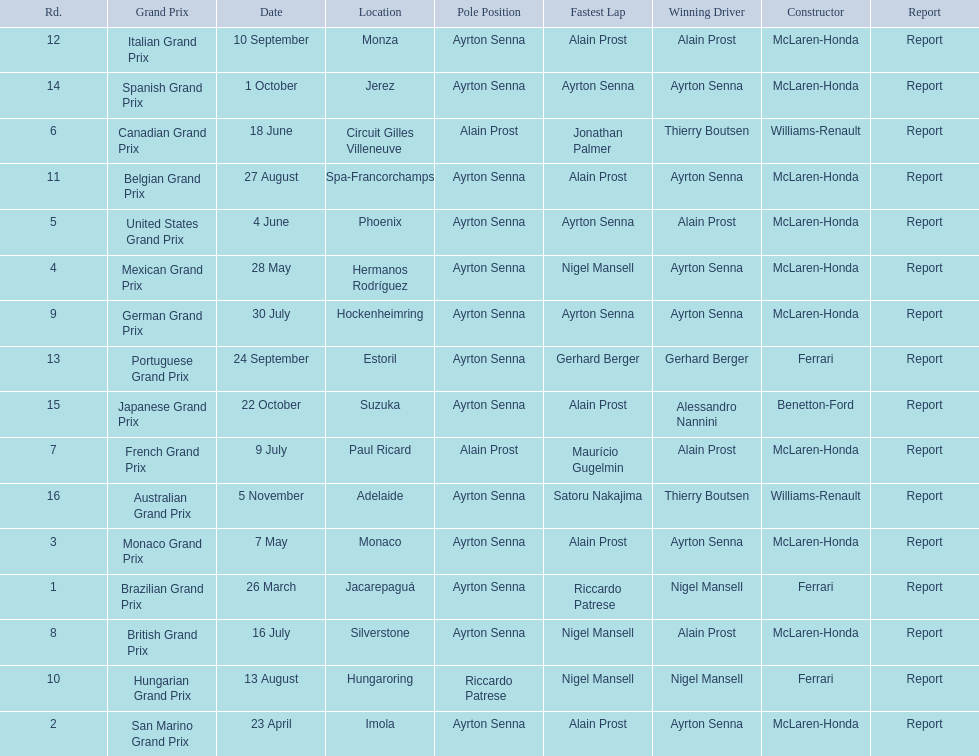Would you mind parsing the complete table? {'header': ['Rd.', 'Grand Prix', 'Date', 'Location', 'Pole Position', 'Fastest Lap', 'Winning Driver', 'Constructor', 'Report'], 'rows': [['12', 'Italian Grand Prix', '10 September', 'Monza', 'Ayrton Senna', 'Alain Prost', 'Alain Prost', 'McLaren-Honda', 'Report'], ['14', 'Spanish Grand Prix', '1 October', 'Jerez', 'Ayrton Senna', 'Ayrton Senna', 'Ayrton Senna', 'McLaren-Honda', 'Report'], ['6', 'Canadian Grand Prix', '18 June', 'Circuit Gilles Villeneuve', 'Alain Prost', 'Jonathan Palmer', 'Thierry Boutsen', 'Williams-Renault', 'Report'], ['11', 'Belgian Grand Prix', '27 August', 'Spa-Francorchamps', 'Ayrton Senna', 'Alain Prost', 'Ayrton Senna', 'McLaren-Honda', 'Report'], ['5', 'United States Grand Prix', '4 June', 'Phoenix', 'Ayrton Senna', 'Ayrton Senna', 'Alain Prost', 'McLaren-Honda', 'Report'], ['4', 'Mexican Grand Prix', '28 May', 'Hermanos Rodríguez', 'Ayrton Senna', 'Nigel Mansell', 'Ayrton Senna', 'McLaren-Honda', 'Report'], ['9', 'German Grand Prix', '30 July', 'Hockenheimring', 'Ayrton Senna', 'Ayrton Senna', 'Ayrton Senna', 'McLaren-Honda', 'Report'], ['13', 'Portuguese Grand Prix', '24 September', 'Estoril', 'Ayrton Senna', 'Gerhard Berger', 'Gerhard Berger', 'Ferrari', 'Report'], ['15', 'Japanese Grand Prix', '22 October', 'Suzuka', 'Ayrton Senna', 'Alain Prost', 'Alessandro Nannini', 'Benetton-Ford', 'Report'], ['7', 'French Grand Prix', '9 July', 'Paul Ricard', 'Alain Prost', 'Maurício Gugelmin', 'Alain Prost', 'McLaren-Honda', 'Report'], ['16', 'Australian Grand Prix', '5 November', 'Adelaide', 'Ayrton Senna', 'Satoru Nakajima', 'Thierry Boutsen', 'Williams-Renault', 'Report'], ['3', 'Monaco Grand Prix', '7 May', 'Monaco', 'Ayrton Senna', 'Alain Prost', 'Ayrton Senna', 'McLaren-Honda', 'Report'], ['1', 'Brazilian Grand Prix', '26 March', 'Jacarepaguá', 'Ayrton Senna', 'Riccardo Patrese', 'Nigel Mansell', 'Ferrari', 'Report'], ['8', 'British Grand Prix', '16 July', 'Silverstone', 'Ayrton Senna', 'Nigel Mansell', 'Alain Prost', 'McLaren-Honda', 'Report'], ['10', 'Hungarian Grand Prix', '13 August', 'Hungaroring', 'Riccardo Patrese', 'Nigel Mansell', 'Nigel Mansell', 'Ferrari', 'Report'], ['2', 'San Marino Grand Prix', '23 April', 'Imola', 'Ayrton Senna', 'Alain Prost', 'Ayrton Senna', 'McLaren-Honda', 'Report']]} What are all of the grand prix run in the 1989 formula one season? Brazilian Grand Prix, San Marino Grand Prix, Monaco Grand Prix, Mexican Grand Prix, United States Grand Prix, Canadian Grand Prix, French Grand Prix, British Grand Prix, German Grand Prix, Hungarian Grand Prix, Belgian Grand Prix, Italian Grand Prix, Portuguese Grand Prix, Spanish Grand Prix, Japanese Grand Prix, Australian Grand Prix. Of those 1989 formula one grand prix, which were run in october? Spanish Grand Prix, Japanese Grand Prix, Australian Grand Prix. Of those 1989 formula one grand prix run in october, which was the only one to be won by benetton-ford? Japanese Grand Prix. 